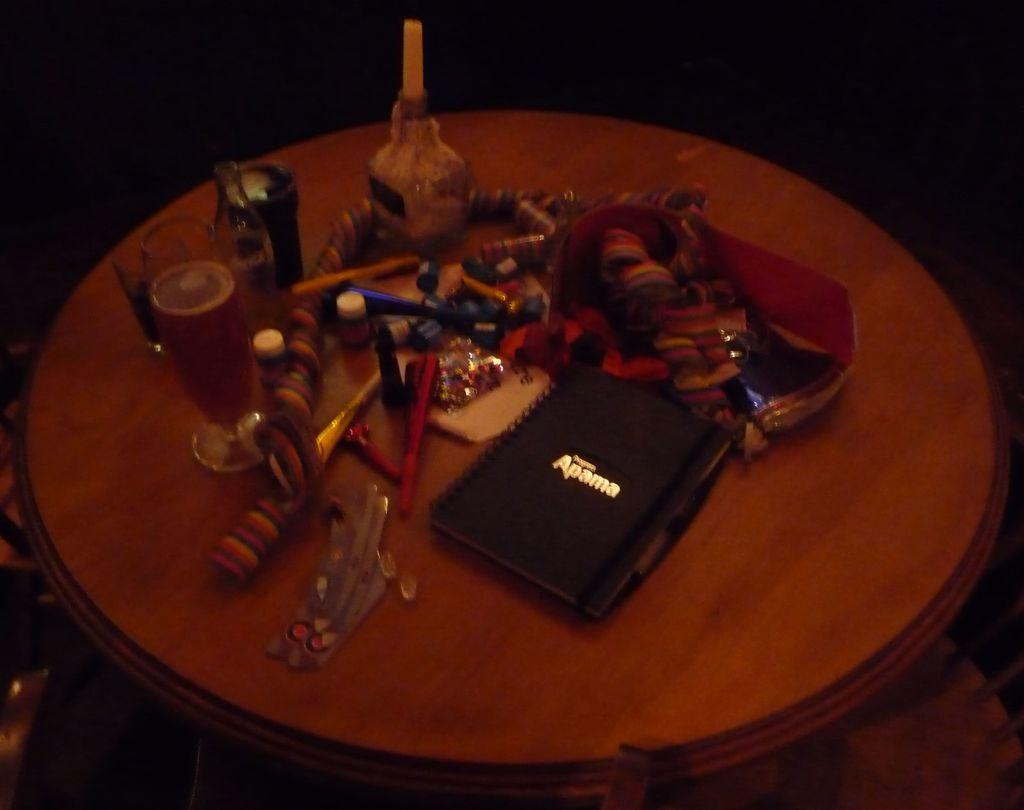<image>
Describe the image concisely. A black Apama notebook sits on a very cluttered table near a glass of beer 